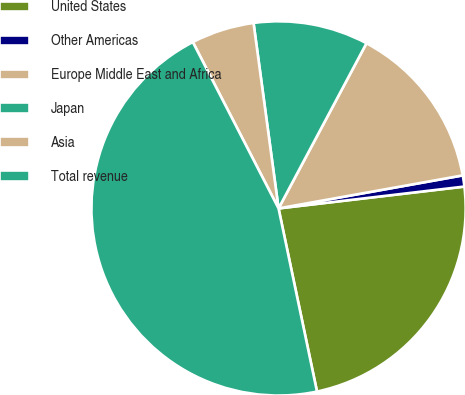<chart> <loc_0><loc_0><loc_500><loc_500><pie_chart><fcel>United States<fcel>Other Americas<fcel>Europe Middle East and Africa<fcel>Japan<fcel>Asia<fcel>Total revenue<nl><fcel>23.57%<fcel>0.96%<fcel>14.39%<fcel>9.92%<fcel>5.44%<fcel>45.72%<nl></chart> 